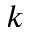Convert formula to latex. <formula><loc_0><loc_0><loc_500><loc_500>k</formula> 